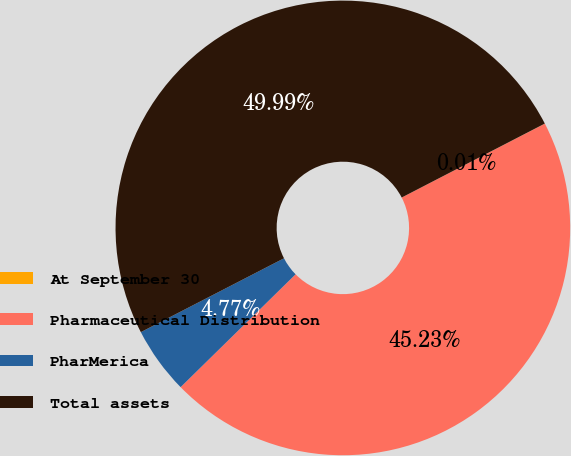Convert chart to OTSL. <chart><loc_0><loc_0><loc_500><loc_500><pie_chart><fcel>At September 30<fcel>Pharmaceutical Distribution<fcel>PharMerica<fcel>Total assets<nl><fcel>0.01%<fcel>45.23%<fcel>4.77%<fcel>49.99%<nl></chart> 